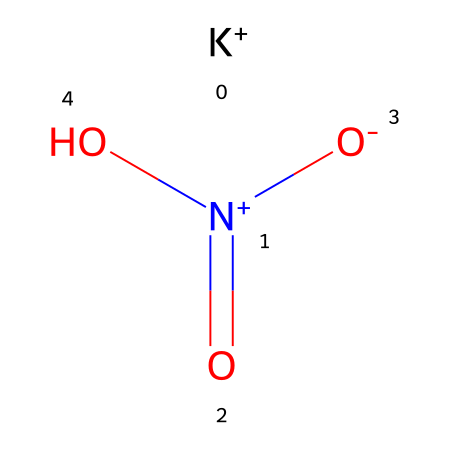What is the molecular formula of potassium nitrate? The SMILES representation indicates the presence of potassium (K), nitrogen (N), and oxygen (O) in the molecule. From the structure, we can infer that there is one potassium atom, one nitrogen atom, and three oxygen atoms. This leads us to the molecular formula KNO3.
Answer: KNO3 How many oxygen atoms are present in potassium nitrate? Analyzing the SMILES representation, there are three oxygen atoms bonded to the nitrogen atom. The notation shows a nitrogen atom connected to two different oxygen nodes, confirming the total count.
Answer: 3 What type of chemical is potassium nitrate? Given that potassium nitrate is an oxidizing agent commonly used in fireworks, the chemical structure and composition clarify that it functions primarily as a nitrate, which is a type of oxidizer.
Answer: oxidizer How many total atoms are in potassium nitrate? The molecular formula KNO3 includes one atom of potassium, one atom of nitrogen, and three atoms of oxygen. Adding these together gives a total of five atoms.
Answer: 5 What central atom in potassium nitrate enables its oxidizing properties? The nitrogen atom is central to the structure and is bonded to three oxygens; this configuration is key to its behavior as an oxidizer due to its ability to release oxygen during combustion, enhancing firework displays.
Answer: nitrogen What is the charge of the potassium ion in potassium nitrate? The SMILES notation shows that potassium (K) is represented without any additional charge symbols, indicating that it carries a single positive charge in this ionic compound.
Answer: +1 